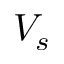Convert formula to latex. <formula><loc_0><loc_0><loc_500><loc_500>V _ { s }</formula> 